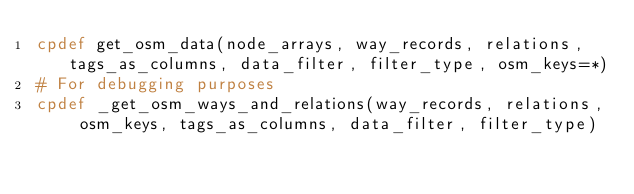<code> <loc_0><loc_0><loc_500><loc_500><_Cython_>cpdef get_osm_data(node_arrays, way_records, relations, tags_as_columns, data_filter, filter_type, osm_keys=*)
# For debugging purposes
cpdef _get_osm_ways_and_relations(way_records, relations, osm_keys, tags_as_columns, data_filter, filter_type)</code> 